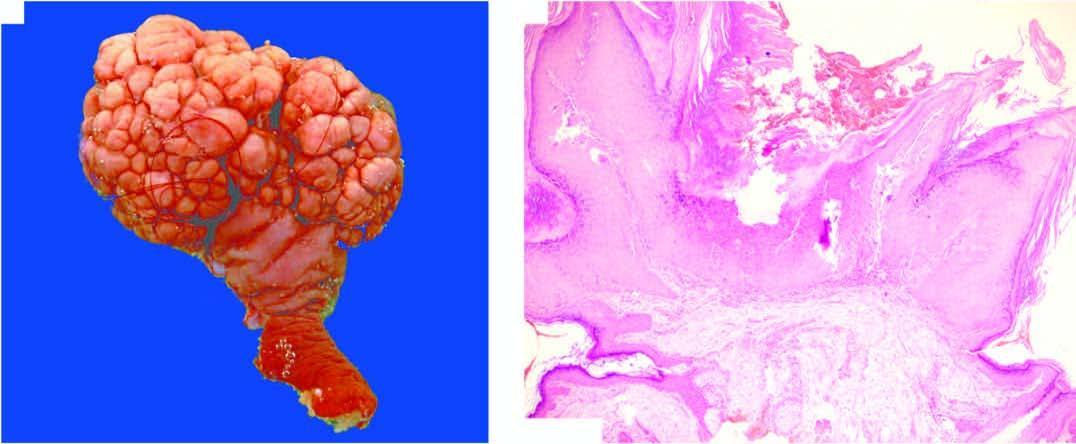s intermediate callus smooth?
Answer the question using a single word or phrase. No 